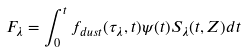Convert formula to latex. <formula><loc_0><loc_0><loc_500><loc_500>F _ { \lambda } = \int _ { 0 } ^ { t } f _ { d u s t } ( \tau _ { \lambda } , t ) \psi ( t ) S _ { \lambda } ( t , Z ) d t</formula> 